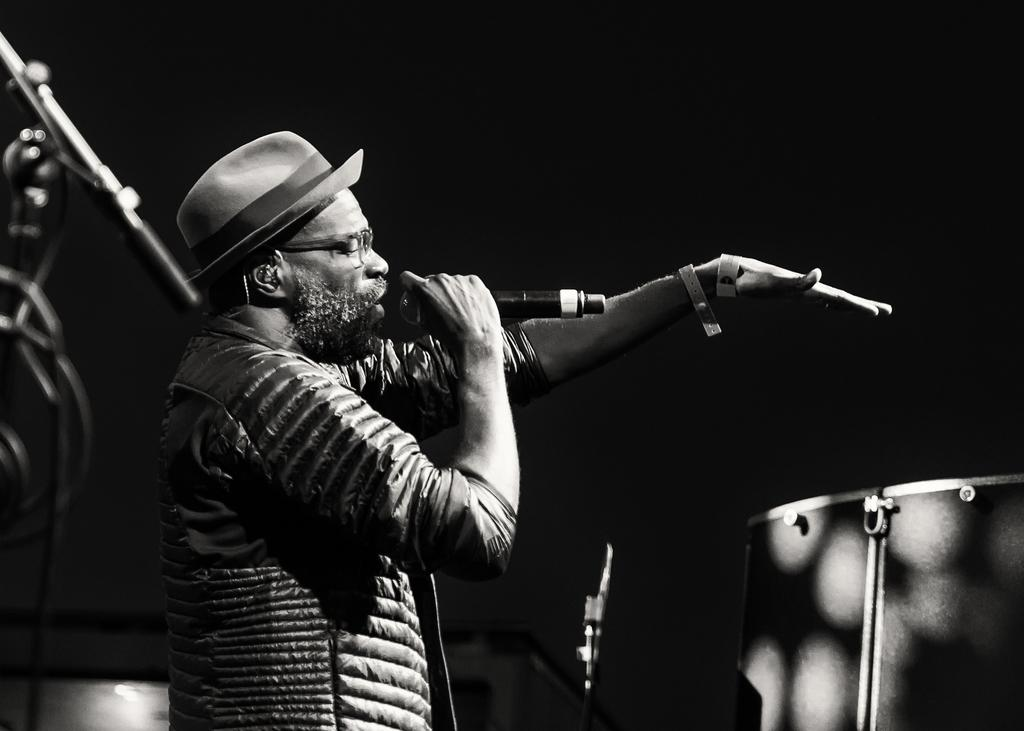What is the man in the image doing? The man is singing in the image. What is the man holding in his hand? The man is holding a microphone in his hand. What can be seen in the background of the image? There is a drum and other objects in the background of the image. What type of friction can be seen between the man and the microphone in the image? There is no friction visible between the man and the microphone in the image. What type of cloth is the man wearing in the image? The provided facts do not mention the type of clothing the man is wearing, so we cannot determine the type of cloth in the image. 